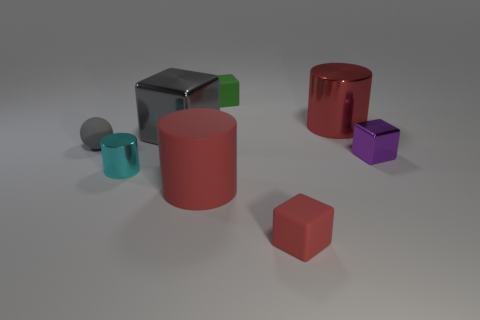Subtract all big matte cylinders. How many cylinders are left? 2 Subtract all red balls. How many red cylinders are left? 2 Add 1 purple metal objects. How many objects exist? 9 Subtract all cylinders. How many objects are left? 5 Subtract all red blocks. How many blocks are left? 3 Subtract 2 cylinders. How many cylinders are left? 1 Subtract all small cyan metallic things. Subtract all big red matte things. How many objects are left? 6 Add 6 big matte things. How many big matte things are left? 7 Add 3 tiny red metal spheres. How many tiny red metal spheres exist? 3 Subtract 0 blue blocks. How many objects are left? 8 